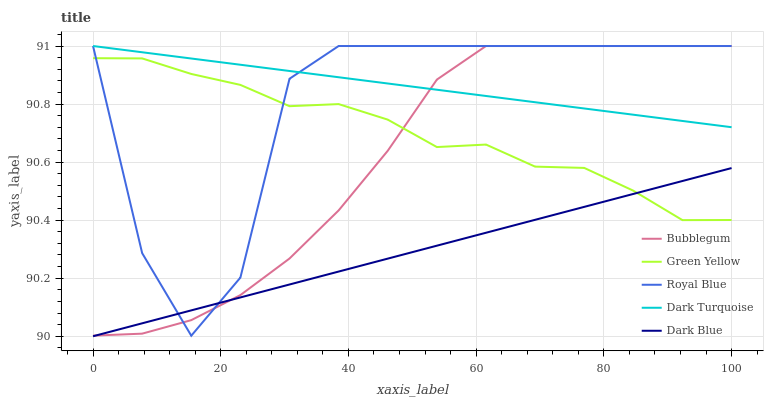Does Dark Blue have the minimum area under the curve?
Answer yes or no. Yes. Does Dark Turquoise have the maximum area under the curve?
Answer yes or no. Yes. Does Green Yellow have the minimum area under the curve?
Answer yes or no. No. Does Green Yellow have the maximum area under the curve?
Answer yes or no. No. Is Dark Blue the smoothest?
Answer yes or no. Yes. Is Royal Blue the roughest?
Answer yes or no. Yes. Is Green Yellow the smoothest?
Answer yes or no. No. Is Green Yellow the roughest?
Answer yes or no. No. Does Green Yellow have the lowest value?
Answer yes or no. No. Does Dark Turquoise have the highest value?
Answer yes or no. Yes. Does Green Yellow have the highest value?
Answer yes or no. No. Is Green Yellow less than Dark Turquoise?
Answer yes or no. Yes. Is Dark Turquoise greater than Green Yellow?
Answer yes or no. Yes. Does Green Yellow intersect Dark Turquoise?
Answer yes or no. No. 